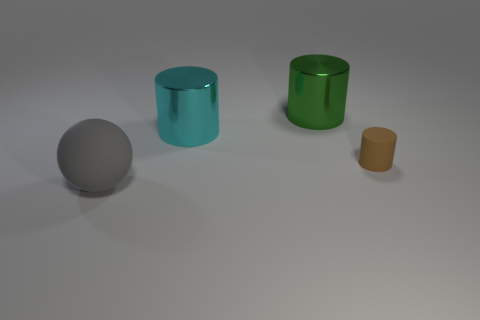What number of brown objects are matte balls or small cylinders?
Your answer should be compact. 1. Is the cyan shiny thing the same shape as the tiny brown matte thing?
Make the answer very short. Yes. There is a thing that is in front of the small cylinder; is there a tiny matte cylinder to the right of it?
Your answer should be very brief. Yes. Is the number of large cylinders left of the big cyan cylinder the same as the number of small yellow metal spheres?
Give a very brief answer. Yes. What number of other objects are the same size as the green metal cylinder?
Provide a short and direct response. 2. Does the cylinder right of the large green cylinder have the same material as the thing that is in front of the brown thing?
Your response must be concise. Yes. There is a matte thing that is left of the matte thing behind the gray matte thing; what size is it?
Keep it short and to the point. Large. Is there a object that has the same color as the rubber ball?
Provide a short and direct response. No. Does the large thing in front of the tiny brown object have the same color as the matte object that is behind the large matte object?
Your response must be concise. No. There is a big green metal object; what shape is it?
Provide a short and direct response. Cylinder. 